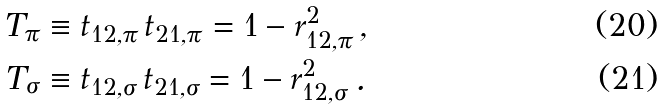<formula> <loc_0><loc_0><loc_500><loc_500>T _ { \pi } & \equiv t _ { 1 2 , \pi } \, t _ { 2 1 , \pi } = 1 - r _ { 1 2 , \pi } ^ { 2 } \, , \\ T _ { \sigma } & \equiv t _ { 1 2 , \sigma } \, t _ { 2 1 , \sigma } = 1 - r _ { 1 2 , \sigma } ^ { 2 } \, .</formula> 